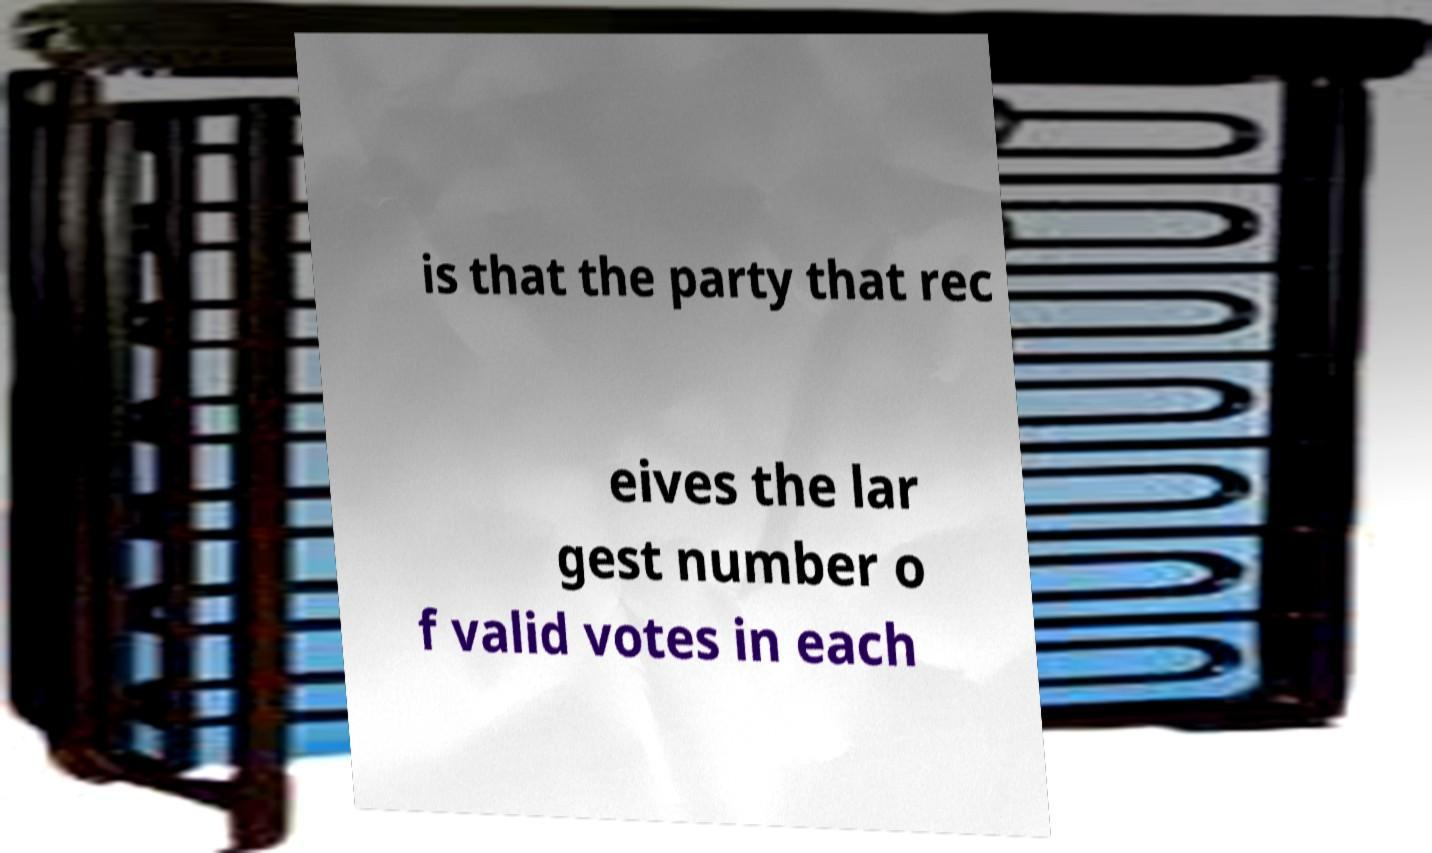I need the written content from this picture converted into text. Can you do that? is that the party that rec eives the lar gest number o f valid votes in each 